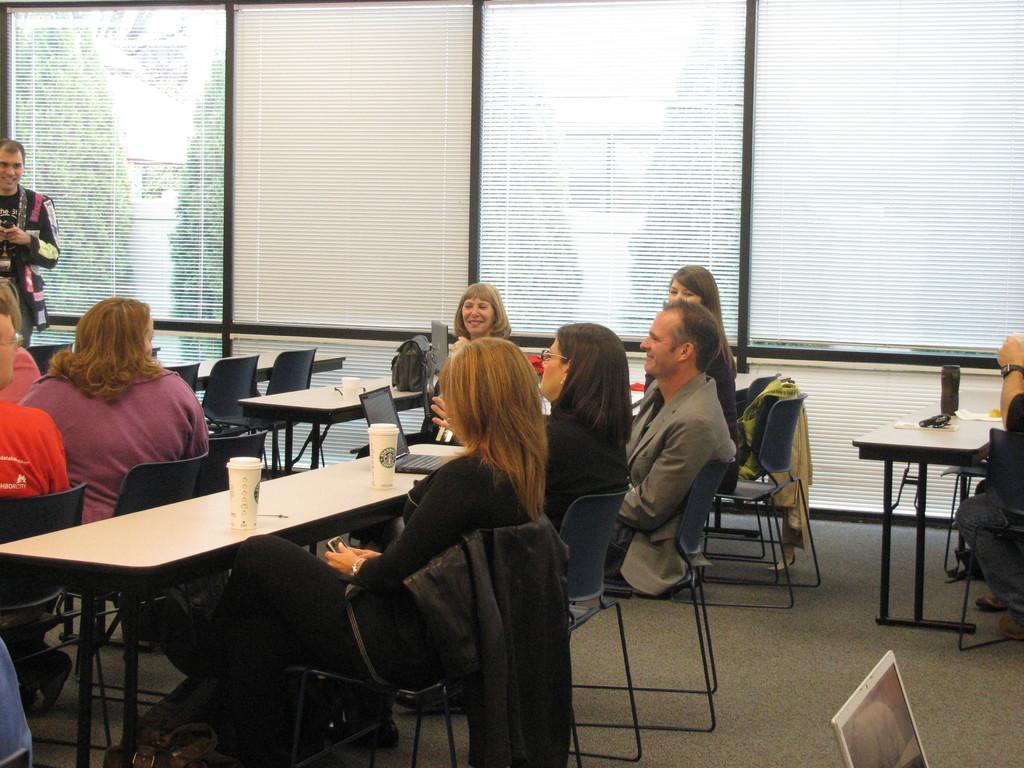How would you summarize this image in a sentence or two? In the middle of the image there are some table and chairs on the table there are some cups and laptops. Surrounding the tables few people are sitting on the chairs. Behind them there is a glass window. Through the glass window we can see some trees. 